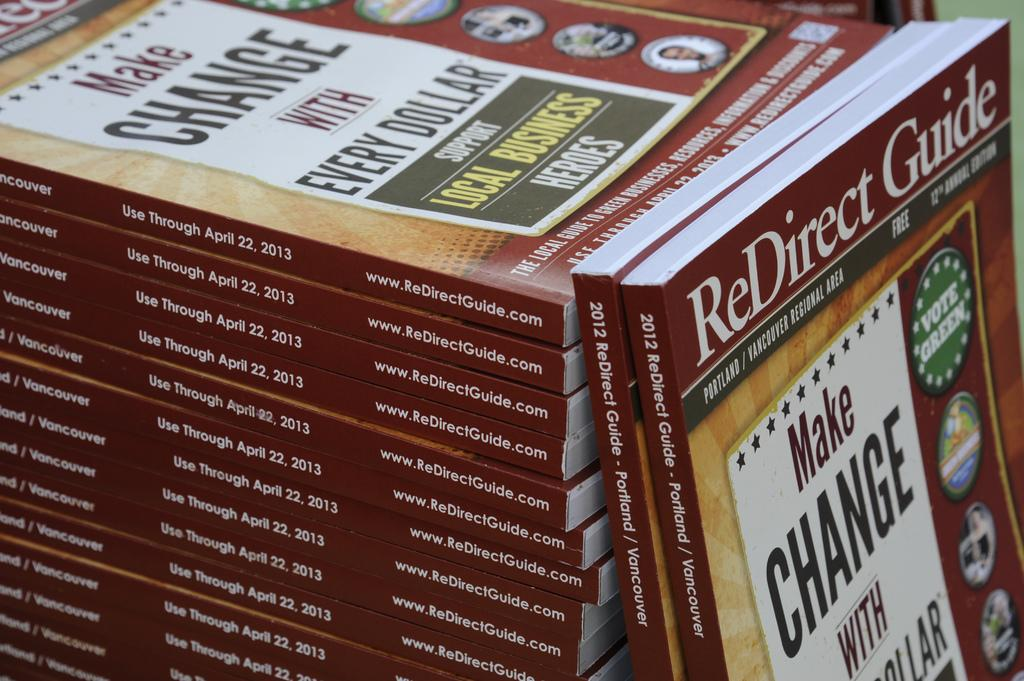<image>
Offer a succinct explanation of the picture presented. Many books titled ReDirect Guide stacked on top of eachother. 